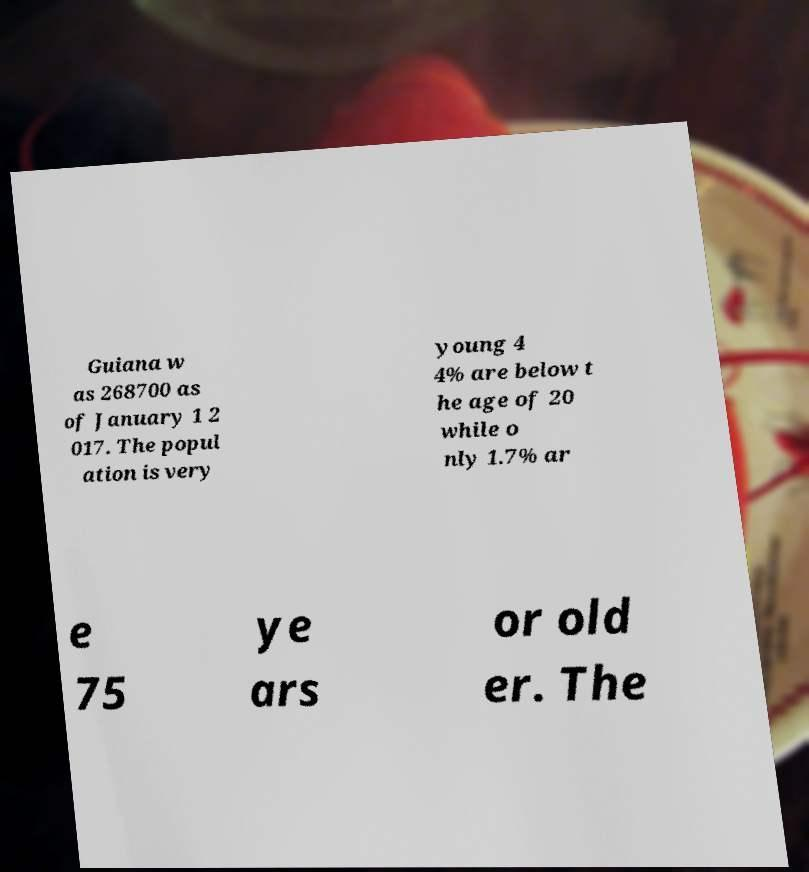Can you accurately transcribe the text from the provided image for me? Guiana w as 268700 as of January 1 2 017. The popul ation is very young 4 4% are below t he age of 20 while o nly 1.7% ar e 75 ye ars or old er. The 